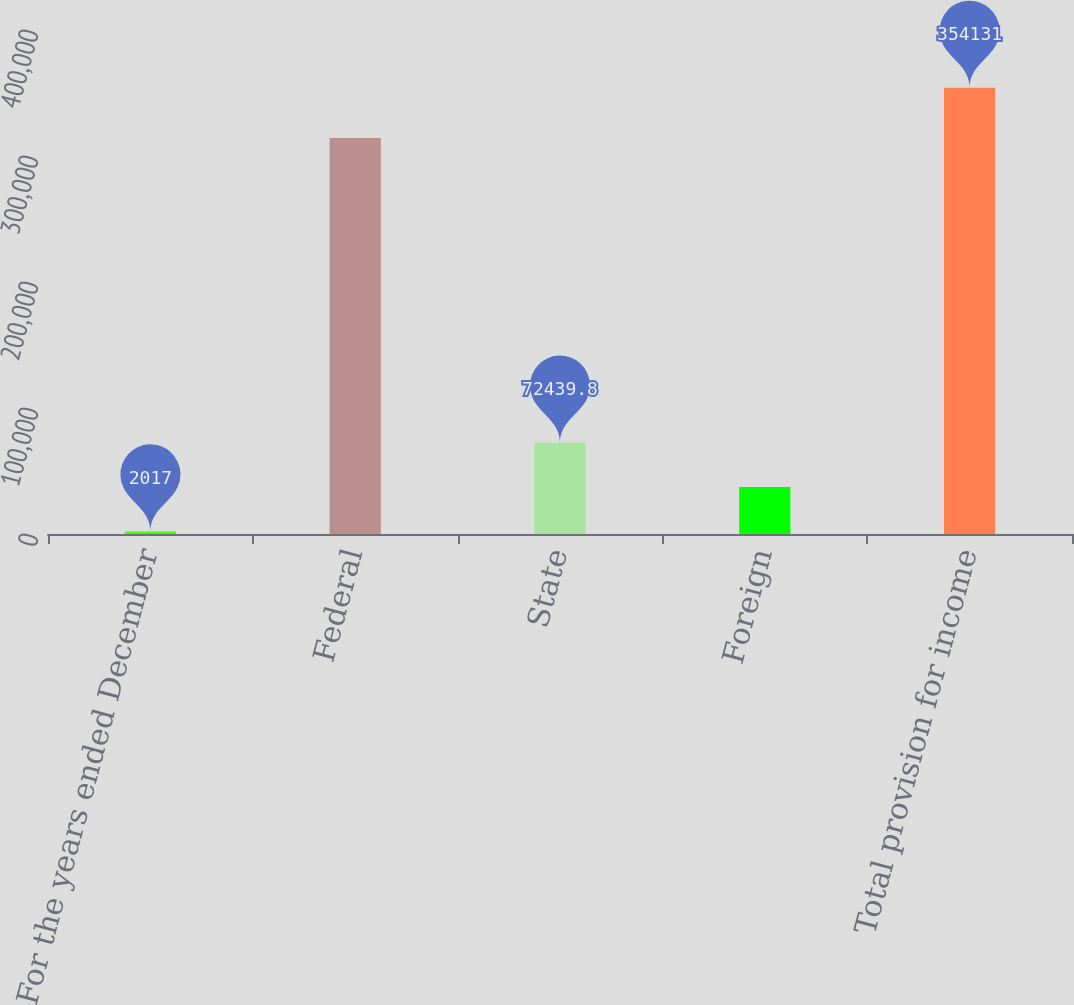Convert chart to OTSL. <chart><loc_0><loc_0><loc_500><loc_500><bar_chart><fcel>For the years ended December<fcel>Federal<fcel>State<fcel>Foreign<fcel>Total provision for income<nl><fcel>2017<fcel>314277<fcel>72439.8<fcel>37228.4<fcel>354131<nl></chart> 